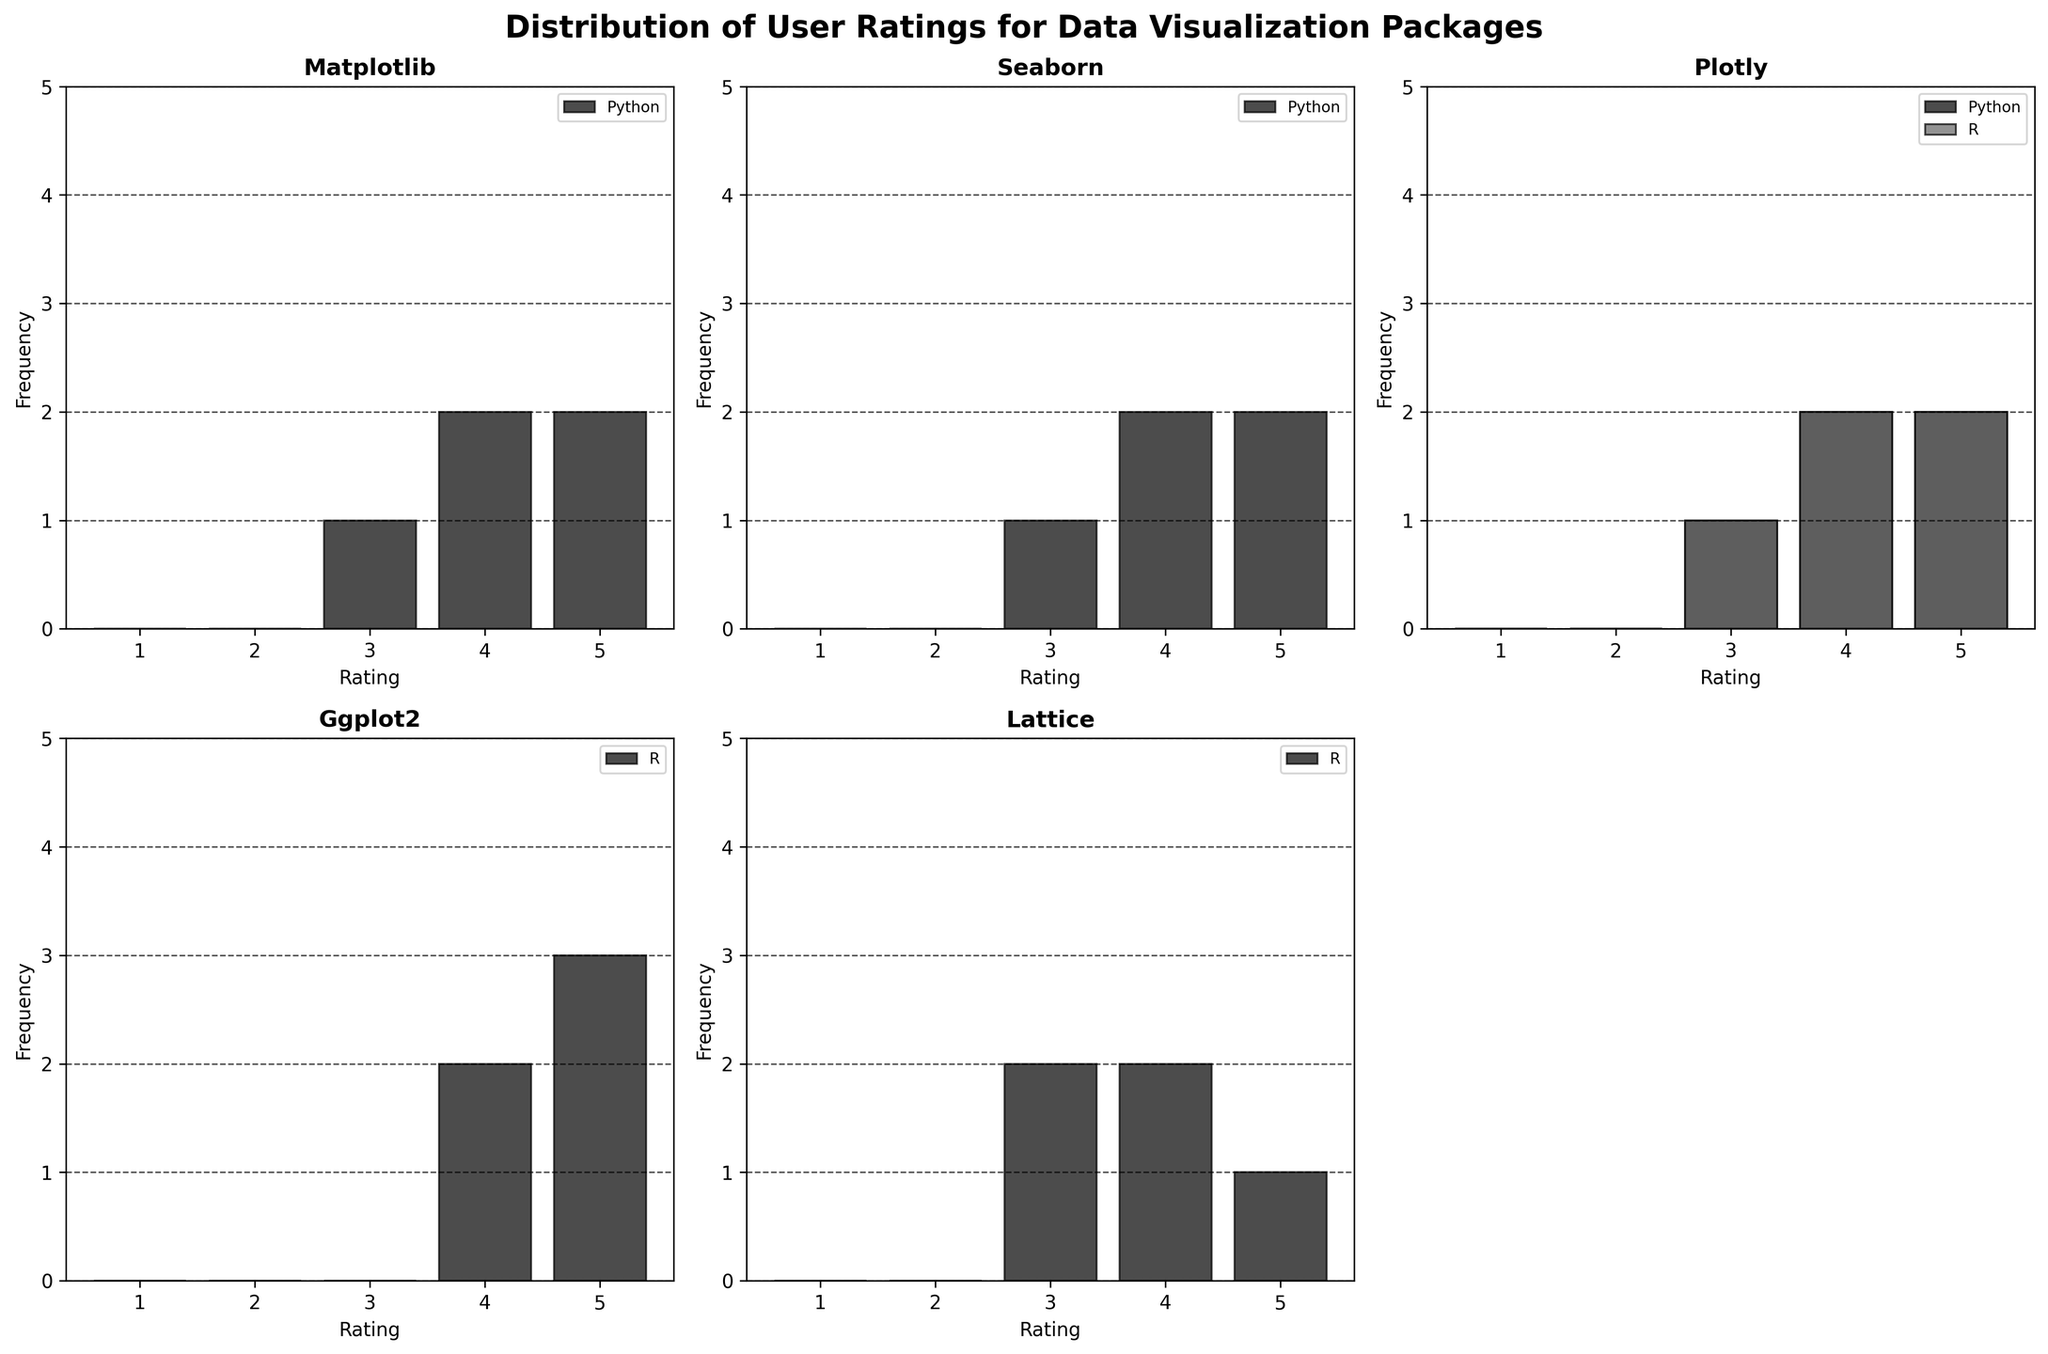What is the average rating for the Seaborn package in the Python ecosystem? To find the average, sum all the ratings for Seaborn within the Python ecosystem and divide by the number of ratings. The ratings are 5, 4, 5, 3, and 4. Summation = 5 + 4 + 5 + 3 + 4 = 21. Number of ratings = 5. Average = 21/5 = 4.2
Answer: 4.2 Which package has the highest number of ratings of 5 in the Python ecosystem? Compare the number of ratings equal to 5 for each package within the Python ecosystem. Matplotlib has 2, Seaborn has 2, Plotly has 2. Since they all share this number, there is no clear single package with a higher amount.
Answer: All tied (Matplotlib, Seaborn, Plotly) Do any packages have the same distribution of ratings for the Python ecosystem? Compare the histograms for each package within the Python ecosystem. Matplotlib's distribution is 3, 4, 4, 5, 5. Seaborn's is 3, 4, 4, 5, 5. Plotly's is 3, 4, 4, 5, 5. All three packages have the same distribution of ratings.
Answer: Yes, Matplotlib, Seaborn, Plotly What is the most frequent rating for `ggplot2` in the R ecosystem? Check the histogram for `ggplot2` in the R ecosystem. The most bars occur at rating 5.
Answer: 5 Which ecosystem has a higher number of ratings for the `plotly` package? Compare the total ratings for `plotly` in both ecosystems. Python's ratings: 5, 4, 5, 4, 3. Total = 5. R's ratings: 4, 5, 3, 4, 5. Total = 5. They have the same number of ratings.
Answer: Equal (Python = 5, R = 5) How does the rating distribution of `lattice` in the R ecosystem compare to Matplotlib in Python? Compare the histograms of both packages in their respective ecosystems. `Lattice` distribution (R): 3, 4, 3, 4, 5; `Matplotlib` (Python): 3, 4, 4, 5, 5. Differences lie in individual counts. Matplotlib has more 5's, equal 3's and 4's compare.
Answer: Matplotlib has more 5’s What is the median rating for the `lattice` package in the R ecosystem? Sort the ratings and find the middle value. The ratings for `lattice` in R are 3, 3, 4, 4, and 5. The median is the middle value, which is 4.
Answer: 4 